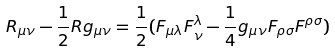Convert formula to latex. <formula><loc_0><loc_0><loc_500><loc_500>R _ { \mu \nu } - \frac { 1 } { 2 } R g _ { \mu \nu } = \frac { 1 } { 2 } ( F _ { \mu \lambda } F _ { \nu } ^ { \lambda } - \frac { 1 } { 4 } g _ { \mu \nu } F _ { \rho \sigma } F ^ { \rho \sigma } )</formula> 